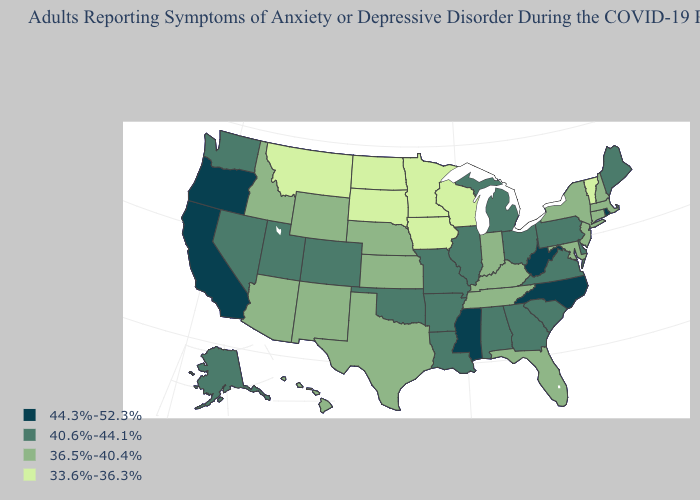Among the states that border Georgia , does Tennessee have the lowest value?
Give a very brief answer. Yes. Which states have the highest value in the USA?
Concise answer only. California, Mississippi, North Carolina, Oregon, Rhode Island, West Virginia. Name the states that have a value in the range 33.6%-36.3%?
Concise answer only. Iowa, Minnesota, Montana, North Dakota, South Dakota, Vermont, Wisconsin. What is the lowest value in the USA?
Give a very brief answer. 33.6%-36.3%. Does South Carolina have a lower value than Oregon?
Be succinct. Yes. Does Alaska have a higher value than Oklahoma?
Concise answer only. No. Name the states that have a value in the range 44.3%-52.3%?
Be succinct. California, Mississippi, North Carolina, Oregon, Rhode Island, West Virginia. How many symbols are there in the legend?
Quick response, please. 4. Among the states that border Arizona , does Nevada have the lowest value?
Quick response, please. No. Does Maine have the same value as Wisconsin?
Keep it brief. No. Name the states that have a value in the range 44.3%-52.3%?
Quick response, please. California, Mississippi, North Carolina, Oregon, Rhode Island, West Virginia. What is the value of Indiana?
Write a very short answer. 36.5%-40.4%. What is the value of Alabama?
Quick response, please. 40.6%-44.1%. Name the states that have a value in the range 33.6%-36.3%?
Answer briefly. Iowa, Minnesota, Montana, North Dakota, South Dakota, Vermont, Wisconsin. Does Hawaii have the highest value in the USA?
Answer briefly. No. 